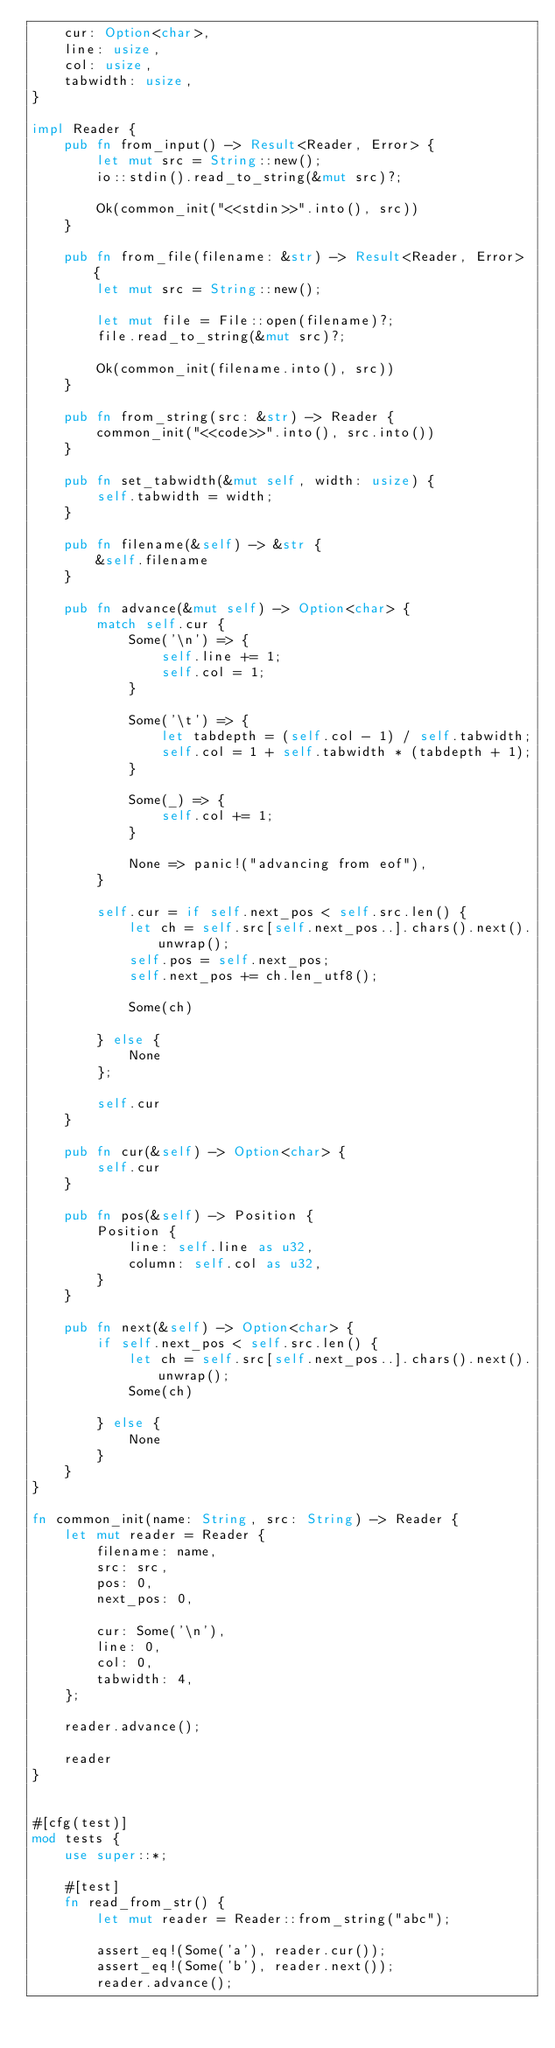<code> <loc_0><loc_0><loc_500><loc_500><_Rust_>    cur: Option<char>,
    line: usize,
    col: usize,
    tabwidth: usize,
}

impl Reader {
    pub fn from_input() -> Result<Reader, Error> {
        let mut src = String::new();
        io::stdin().read_to_string(&mut src)?;

        Ok(common_init("<<stdin>>".into(), src))
    }

    pub fn from_file(filename: &str) -> Result<Reader, Error> {
        let mut src = String::new();

        let mut file = File::open(filename)?;
        file.read_to_string(&mut src)?;

        Ok(common_init(filename.into(), src))
    }

    pub fn from_string(src: &str) -> Reader {
        common_init("<<code>>".into(), src.into())
    }

    pub fn set_tabwidth(&mut self, width: usize) {
        self.tabwidth = width;
    }

    pub fn filename(&self) -> &str {
        &self.filename
    }

    pub fn advance(&mut self) -> Option<char> {
        match self.cur {
            Some('\n') => {
                self.line += 1;
                self.col = 1;
            }

            Some('\t') => {
                let tabdepth = (self.col - 1) / self.tabwidth;
                self.col = 1 + self.tabwidth * (tabdepth + 1);
            }

            Some(_) => {
                self.col += 1;
            }

            None => panic!("advancing from eof"),
        }

        self.cur = if self.next_pos < self.src.len() {
            let ch = self.src[self.next_pos..].chars().next().unwrap();
            self.pos = self.next_pos;
            self.next_pos += ch.len_utf8();

            Some(ch)

        } else {
            None
        };

        self.cur
    }

    pub fn cur(&self) -> Option<char> {
        self.cur
    }

    pub fn pos(&self) -> Position {
        Position {
            line: self.line as u32,
            column: self.col as u32,
        }
    }

    pub fn next(&self) -> Option<char> {
        if self.next_pos < self.src.len() {
            let ch = self.src[self.next_pos..].chars().next().unwrap();
            Some(ch)

        } else {
            None
        }
    }
}

fn common_init(name: String, src: String) -> Reader {
    let mut reader = Reader {
        filename: name,
        src: src,
        pos: 0,
        next_pos: 0,

        cur: Some('\n'),
        line: 0,
        col: 0,
        tabwidth: 4,
    };

    reader.advance();

    reader
}


#[cfg(test)]
mod tests {
    use super::*;

    #[test]
    fn read_from_str() {
        let mut reader = Reader::from_string("abc");

        assert_eq!(Some('a'), reader.cur());
        assert_eq!(Some('b'), reader.next());
        reader.advance();
</code> 